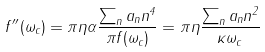Convert formula to latex. <formula><loc_0><loc_0><loc_500><loc_500>f ^ { \prime \prime } ( \omega _ { c } ) = \pi \eta \alpha \frac { \sum _ { n } a _ { n } n ^ { 4 } } { \pi f ( \omega _ { c } ) } = \pi \eta \frac { \sum _ { n } a _ { n } n ^ { 2 } } { \kappa \omega _ { c } }</formula> 